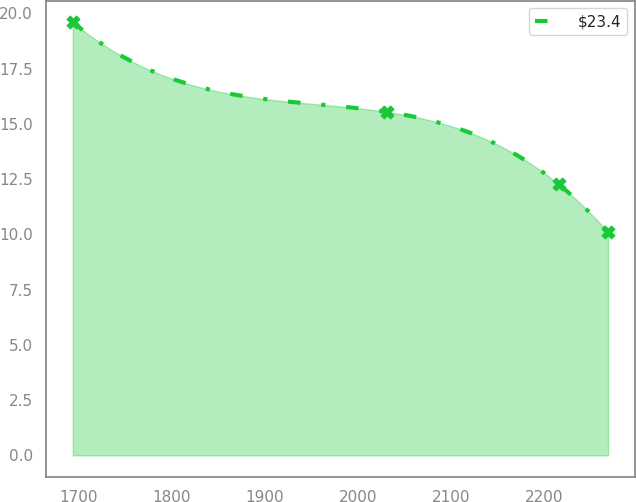Convert chart to OTSL. <chart><loc_0><loc_0><loc_500><loc_500><line_chart><ecel><fcel>$23.4<nl><fcel>1694.01<fcel>19.6<nl><fcel>2031.17<fcel>15.54<nl><fcel>2215.64<fcel>12.27<nl><fcel>2268.81<fcel>10.09<nl></chart> 